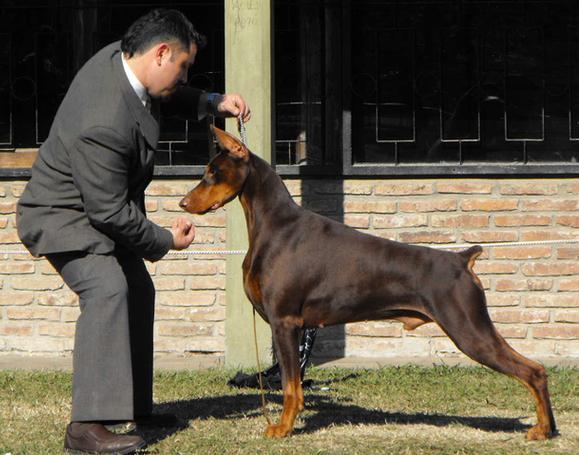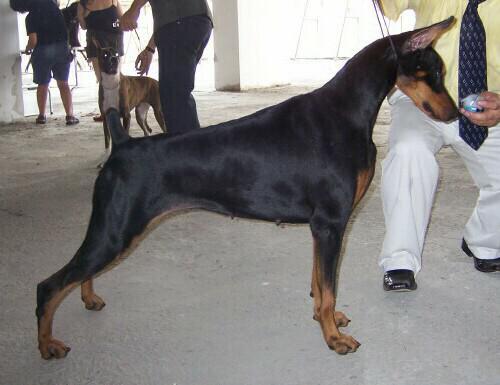The first image is the image on the left, the second image is the image on the right. Considering the images on both sides, is "The left image contains one dog facing towards the left." valid? Answer yes or no. Yes. 